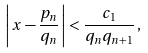<formula> <loc_0><loc_0><loc_500><loc_500>\left | \, x - \frac { p _ { n } } { q _ { n } } \, \right | < \frac { c _ { 1 } } { q _ { n } q _ { n + 1 } } \, ,</formula> 